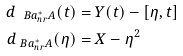Convert formula to latex. <formula><loc_0><loc_0><loc_500><loc_500>d _ { \ B a _ { n r } ^ { * } A } ( t ) & = Y ( t ) - [ \eta , t ] \\ d _ { \ B a _ { n r } ^ { * } A } ( \eta ) & = X - \eta ^ { 2 }</formula> 